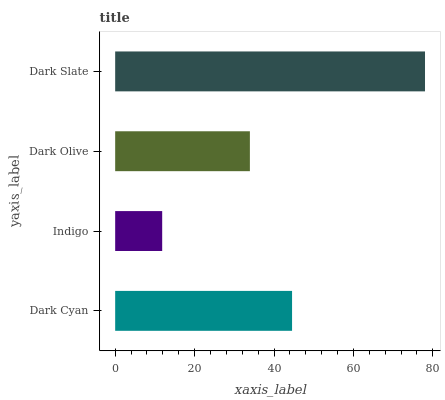Is Indigo the minimum?
Answer yes or no. Yes. Is Dark Slate the maximum?
Answer yes or no. Yes. Is Dark Olive the minimum?
Answer yes or no. No. Is Dark Olive the maximum?
Answer yes or no. No. Is Dark Olive greater than Indigo?
Answer yes or no. Yes. Is Indigo less than Dark Olive?
Answer yes or no. Yes. Is Indigo greater than Dark Olive?
Answer yes or no. No. Is Dark Olive less than Indigo?
Answer yes or no. No. Is Dark Cyan the high median?
Answer yes or no. Yes. Is Dark Olive the low median?
Answer yes or no. Yes. Is Dark Slate the high median?
Answer yes or no. No. Is Dark Slate the low median?
Answer yes or no. No. 